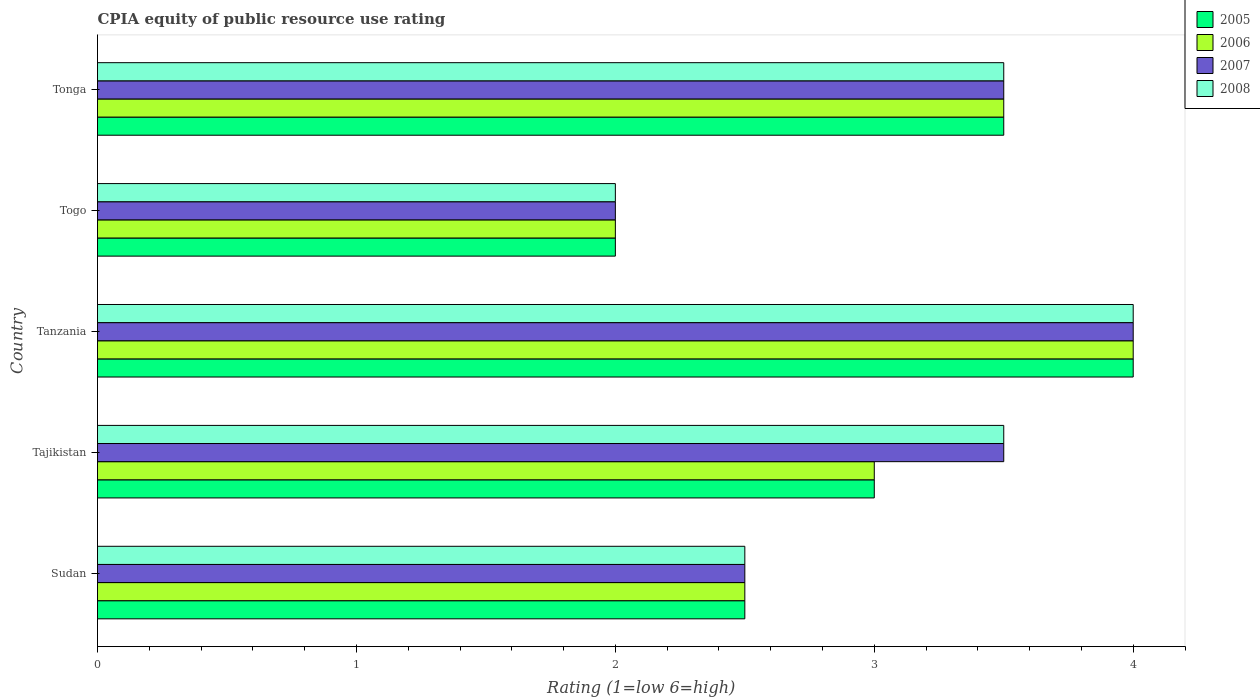How many bars are there on the 2nd tick from the top?
Make the answer very short. 4. What is the label of the 4th group of bars from the top?
Offer a very short reply. Tajikistan. In how many cases, is the number of bars for a given country not equal to the number of legend labels?
Keep it short and to the point. 0. What is the CPIA rating in 2007 in Sudan?
Your answer should be very brief. 2.5. Across all countries, what is the minimum CPIA rating in 2005?
Offer a very short reply. 2. In which country was the CPIA rating in 2008 maximum?
Give a very brief answer. Tanzania. In which country was the CPIA rating in 2005 minimum?
Give a very brief answer. Togo. What is the total CPIA rating in 2007 in the graph?
Keep it short and to the point. 15.5. What is the difference between the CPIA rating in 2005 in Tajikistan and that in Togo?
Provide a short and direct response. 1. What is the difference between the CPIA rating in 2005 in Sudan and the CPIA rating in 2008 in Togo?
Provide a short and direct response. 0.5. What is the average CPIA rating in 2006 per country?
Your answer should be very brief. 3. What is the difference between the CPIA rating in 2006 and CPIA rating in 2007 in Togo?
Your answer should be very brief. 0. What is the ratio of the CPIA rating in 2007 in Togo to that in Tonga?
Give a very brief answer. 0.57. Is the CPIA rating in 2006 in Sudan less than that in Tajikistan?
Provide a short and direct response. Yes. What is the difference between the highest and the second highest CPIA rating in 2007?
Make the answer very short. 0.5. In how many countries, is the CPIA rating in 2007 greater than the average CPIA rating in 2007 taken over all countries?
Your answer should be compact. 3. Is the sum of the CPIA rating in 2007 in Sudan and Togo greater than the maximum CPIA rating in 2006 across all countries?
Your answer should be very brief. Yes. Is it the case that in every country, the sum of the CPIA rating in 2005 and CPIA rating in 2007 is greater than the sum of CPIA rating in 2006 and CPIA rating in 2008?
Give a very brief answer. No. What does the 3rd bar from the top in Togo represents?
Provide a succinct answer. 2006. What does the 2nd bar from the bottom in Tajikistan represents?
Make the answer very short. 2006. How many bars are there?
Give a very brief answer. 20. What is the difference between two consecutive major ticks on the X-axis?
Give a very brief answer. 1. Are the values on the major ticks of X-axis written in scientific E-notation?
Your answer should be compact. No. Does the graph contain grids?
Provide a short and direct response. No. Where does the legend appear in the graph?
Ensure brevity in your answer.  Top right. How many legend labels are there?
Provide a short and direct response. 4. What is the title of the graph?
Offer a very short reply. CPIA equity of public resource use rating. What is the label or title of the Y-axis?
Give a very brief answer. Country. What is the Rating (1=low 6=high) in 2008 in Sudan?
Give a very brief answer. 2.5. What is the Rating (1=low 6=high) in 2007 in Tajikistan?
Provide a succinct answer. 3.5. What is the Rating (1=low 6=high) of 2008 in Tajikistan?
Your answer should be very brief. 3.5. What is the Rating (1=low 6=high) of 2007 in Tanzania?
Offer a very short reply. 4. What is the Rating (1=low 6=high) in 2006 in Togo?
Provide a succinct answer. 2. What is the Rating (1=low 6=high) of 2007 in Togo?
Provide a succinct answer. 2. Across all countries, what is the maximum Rating (1=low 6=high) of 2005?
Offer a terse response. 4. What is the total Rating (1=low 6=high) of 2005 in the graph?
Ensure brevity in your answer.  15. What is the total Rating (1=low 6=high) of 2006 in the graph?
Make the answer very short. 15. What is the total Rating (1=low 6=high) in 2007 in the graph?
Make the answer very short. 15.5. What is the difference between the Rating (1=low 6=high) in 2005 in Sudan and that in Tajikistan?
Ensure brevity in your answer.  -0.5. What is the difference between the Rating (1=low 6=high) of 2006 in Sudan and that in Tajikistan?
Provide a succinct answer. -0.5. What is the difference between the Rating (1=low 6=high) of 2007 in Sudan and that in Tajikistan?
Ensure brevity in your answer.  -1. What is the difference between the Rating (1=low 6=high) of 2007 in Sudan and that in Tanzania?
Your answer should be very brief. -1.5. What is the difference between the Rating (1=low 6=high) in 2008 in Sudan and that in Tanzania?
Provide a succinct answer. -1.5. What is the difference between the Rating (1=low 6=high) of 2006 in Sudan and that in Tonga?
Your answer should be very brief. -1. What is the difference between the Rating (1=low 6=high) in 2007 in Sudan and that in Tonga?
Keep it short and to the point. -1. What is the difference between the Rating (1=low 6=high) in 2007 in Tajikistan and that in Tanzania?
Your answer should be compact. -0.5. What is the difference between the Rating (1=low 6=high) of 2008 in Tajikistan and that in Tanzania?
Your answer should be compact. -0.5. What is the difference between the Rating (1=low 6=high) of 2005 in Tajikistan and that in Togo?
Make the answer very short. 1. What is the difference between the Rating (1=low 6=high) of 2006 in Tajikistan and that in Togo?
Offer a very short reply. 1. What is the difference between the Rating (1=low 6=high) in 2007 in Tajikistan and that in Togo?
Offer a very short reply. 1.5. What is the difference between the Rating (1=low 6=high) in 2006 in Tanzania and that in Tonga?
Make the answer very short. 0.5. What is the difference between the Rating (1=low 6=high) of 2005 in Togo and that in Tonga?
Offer a terse response. -1.5. What is the difference between the Rating (1=low 6=high) in 2008 in Togo and that in Tonga?
Give a very brief answer. -1.5. What is the difference between the Rating (1=low 6=high) in 2005 in Sudan and the Rating (1=low 6=high) in 2006 in Tajikistan?
Your answer should be compact. -0.5. What is the difference between the Rating (1=low 6=high) of 2005 in Sudan and the Rating (1=low 6=high) of 2008 in Tajikistan?
Make the answer very short. -1. What is the difference between the Rating (1=low 6=high) of 2006 in Sudan and the Rating (1=low 6=high) of 2007 in Tajikistan?
Ensure brevity in your answer.  -1. What is the difference between the Rating (1=low 6=high) of 2007 in Sudan and the Rating (1=low 6=high) of 2008 in Tajikistan?
Make the answer very short. -1. What is the difference between the Rating (1=low 6=high) in 2005 in Sudan and the Rating (1=low 6=high) in 2007 in Tanzania?
Ensure brevity in your answer.  -1.5. What is the difference between the Rating (1=low 6=high) in 2006 in Sudan and the Rating (1=low 6=high) in 2007 in Tanzania?
Your answer should be compact. -1.5. What is the difference between the Rating (1=low 6=high) of 2006 in Sudan and the Rating (1=low 6=high) of 2008 in Tanzania?
Give a very brief answer. -1.5. What is the difference between the Rating (1=low 6=high) in 2005 in Sudan and the Rating (1=low 6=high) in 2007 in Togo?
Offer a terse response. 0.5. What is the difference between the Rating (1=low 6=high) in 2006 in Sudan and the Rating (1=low 6=high) in 2007 in Togo?
Give a very brief answer. 0.5. What is the difference between the Rating (1=low 6=high) of 2006 in Sudan and the Rating (1=low 6=high) of 2008 in Togo?
Your response must be concise. 0.5. What is the difference between the Rating (1=low 6=high) of 2005 in Sudan and the Rating (1=low 6=high) of 2006 in Tonga?
Your answer should be compact. -1. What is the difference between the Rating (1=low 6=high) in 2005 in Sudan and the Rating (1=low 6=high) in 2007 in Tonga?
Your answer should be compact. -1. What is the difference between the Rating (1=low 6=high) of 2007 in Sudan and the Rating (1=low 6=high) of 2008 in Tonga?
Your response must be concise. -1. What is the difference between the Rating (1=low 6=high) of 2005 in Tajikistan and the Rating (1=low 6=high) of 2007 in Tanzania?
Your answer should be very brief. -1. What is the difference between the Rating (1=low 6=high) in 2005 in Tajikistan and the Rating (1=low 6=high) in 2008 in Tanzania?
Provide a succinct answer. -1. What is the difference between the Rating (1=low 6=high) in 2006 in Tajikistan and the Rating (1=low 6=high) in 2007 in Tanzania?
Your answer should be very brief. -1. What is the difference between the Rating (1=low 6=high) in 2007 in Tajikistan and the Rating (1=low 6=high) in 2008 in Tanzania?
Give a very brief answer. -0.5. What is the difference between the Rating (1=low 6=high) of 2005 in Tajikistan and the Rating (1=low 6=high) of 2006 in Togo?
Offer a terse response. 1. What is the difference between the Rating (1=low 6=high) of 2005 in Tajikistan and the Rating (1=low 6=high) of 2007 in Togo?
Your answer should be very brief. 1. What is the difference between the Rating (1=low 6=high) of 2005 in Tajikistan and the Rating (1=low 6=high) of 2008 in Togo?
Offer a terse response. 1. What is the difference between the Rating (1=low 6=high) of 2006 in Tajikistan and the Rating (1=low 6=high) of 2008 in Togo?
Make the answer very short. 1. What is the difference between the Rating (1=low 6=high) in 2007 in Tajikistan and the Rating (1=low 6=high) in 2008 in Togo?
Offer a very short reply. 1.5. What is the difference between the Rating (1=low 6=high) in 2005 in Tajikistan and the Rating (1=low 6=high) in 2007 in Tonga?
Provide a short and direct response. -0.5. What is the difference between the Rating (1=low 6=high) in 2006 in Tajikistan and the Rating (1=low 6=high) in 2008 in Tonga?
Your answer should be compact. -0.5. What is the difference between the Rating (1=low 6=high) of 2007 in Tajikistan and the Rating (1=low 6=high) of 2008 in Tonga?
Offer a terse response. 0. What is the difference between the Rating (1=low 6=high) of 2005 in Tanzania and the Rating (1=low 6=high) of 2006 in Togo?
Keep it short and to the point. 2. What is the difference between the Rating (1=low 6=high) of 2005 in Tanzania and the Rating (1=low 6=high) of 2008 in Togo?
Provide a short and direct response. 2. What is the difference between the Rating (1=low 6=high) in 2006 in Tanzania and the Rating (1=low 6=high) in 2007 in Togo?
Offer a terse response. 2. What is the difference between the Rating (1=low 6=high) of 2006 in Tanzania and the Rating (1=low 6=high) of 2008 in Togo?
Offer a very short reply. 2. What is the difference between the Rating (1=low 6=high) of 2005 in Tanzania and the Rating (1=low 6=high) of 2006 in Tonga?
Offer a terse response. 0.5. What is the difference between the Rating (1=low 6=high) in 2005 in Tanzania and the Rating (1=low 6=high) in 2008 in Tonga?
Provide a short and direct response. 0.5. What is the difference between the Rating (1=low 6=high) of 2006 in Tanzania and the Rating (1=low 6=high) of 2007 in Tonga?
Offer a very short reply. 0.5. What is the difference between the Rating (1=low 6=high) in 2007 in Tanzania and the Rating (1=low 6=high) in 2008 in Tonga?
Your answer should be very brief. 0.5. What is the difference between the Rating (1=low 6=high) in 2005 in Togo and the Rating (1=low 6=high) in 2007 in Tonga?
Your answer should be very brief. -1.5. What is the difference between the Rating (1=low 6=high) of 2005 in Togo and the Rating (1=low 6=high) of 2008 in Tonga?
Give a very brief answer. -1.5. What is the difference between the Rating (1=low 6=high) of 2006 in Togo and the Rating (1=low 6=high) of 2007 in Tonga?
Provide a short and direct response. -1.5. What is the average Rating (1=low 6=high) in 2005 per country?
Your response must be concise. 3. What is the average Rating (1=low 6=high) in 2007 per country?
Give a very brief answer. 3.1. What is the difference between the Rating (1=low 6=high) of 2005 and Rating (1=low 6=high) of 2007 in Sudan?
Your response must be concise. 0. What is the difference between the Rating (1=low 6=high) in 2005 and Rating (1=low 6=high) in 2008 in Tajikistan?
Give a very brief answer. -0.5. What is the difference between the Rating (1=low 6=high) in 2005 and Rating (1=low 6=high) in 2008 in Tanzania?
Offer a very short reply. 0. What is the difference between the Rating (1=low 6=high) of 2006 and Rating (1=low 6=high) of 2008 in Tanzania?
Offer a very short reply. 0. What is the difference between the Rating (1=low 6=high) of 2007 and Rating (1=low 6=high) of 2008 in Tanzania?
Your response must be concise. 0. What is the difference between the Rating (1=low 6=high) in 2005 and Rating (1=low 6=high) in 2007 in Togo?
Offer a terse response. 0. What is the difference between the Rating (1=low 6=high) in 2006 and Rating (1=low 6=high) in 2007 in Togo?
Give a very brief answer. 0. What is the difference between the Rating (1=low 6=high) of 2006 and Rating (1=low 6=high) of 2008 in Togo?
Your answer should be compact. 0. What is the difference between the Rating (1=low 6=high) in 2007 and Rating (1=low 6=high) in 2008 in Togo?
Make the answer very short. 0. What is the difference between the Rating (1=low 6=high) of 2005 and Rating (1=low 6=high) of 2006 in Tonga?
Offer a terse response. 0. What is the difference between the Rating (1=low 6=high) of 2005 and Rating (1=low 6=high) of 2007 in Tonga?
Provide a succinct answer. 0. What is the difference between the Rating (1=low 6=high) of 2005 and Rating (1=low 6=high) of 2008 in Tonga?
Your answer should be compact. 0. What is the difference between the Rating (1=low 6=high) in 2006 and Rating (1=low 6=high) in 2007 in Tonga?
Provide a succinct answer. 0. What is the ratio of the Rating (1=low 6=high) of 2007 in Sudan to that in Tajikistan?
Make the answer very short. 0.71. What is the ratio of the Rating (1=low 6=high) in 2008 in Sudan to that in Tajikistan?
Offer a terse response. 0.71. What is the ratio of the Rating (1=low 6=high) of 2005 in Sudan to that in Tanzania?
Give a very brief answer. 0.62. What is the ratio of the Rating (1=low 6=high) of 2005 in Sudan to that in Togo?
Give a very brief answer. 1.25. What is the ratio of the Rating (1=low 6=high) in 2006 in Sudan to that in Togo?
Offer a very short reply. 1.25. What is the ratio of the Rating (1=low 6=high) of 2007 in Sudan to that in Togo?
Provide a short and direct response. 1.25. What is the ratio of the Rating (1=low 6=high) in 2005 in Sudan to that in Tonga?
Your answer should be very brief. 0.71. What is the ratio of the Rating (1=low 6=high) of 2006 in Sudan to that in Tonga?
Offer a terse response. 0.71. What is the ratio of the Rating (1=low 6=high) in 2007 in Sudan to that in Tonga?
Make the answer very short. 0.71. What is the ratio of the Rating (1=low 6=high) in 2008 in Sudan to that in Tonga?
Provide a short and direct response. 0.71. What is the ratio of the Rating (1=low 6=high) of 2006 in Tajikistan to that in Tanzania?
Provide a succinct answer. 0.75. What is the ratio of the Rating (1=low 6=high) in 2007 in Tajikistan to that in Tanzania?
Offer a very short reply. 0.88. What is the ratio of the Rating (1=low 6=high) in 2008 in Tajikistan to that in Tanzania?
Provide a succinct answer. 0.88. What is the ratio of the Rating (1=low 6=high) in 2006 in Tajikistan to that in Togo?
Keep it short and to the point. 1.5. What is the ratio of the Rating (1=low 6=high) of 2007 in Tajikistan to that in Togo?
Make the answer very short. 1.75. What is the ratio of the Rating (1=low 6=high) of 2005 in Tanzania to that in Tonga?
Provide a short and direct response. 1.14. What is the ratio of the Rating (1=low 6=high) of 2007 in Tanzania to that in Tonga?
Keep it short and to the point. 1.14. What is the ratio of the Rating (1=low 6=high) in 2008 in Tanzania to that in Tonga?
Your answer should be very brief. 1.14. What is the ratio of the Rating (1=low 6=high) in 2006 in Togo to that in Tonga?
Offer a very short reply. 0.57. What is the difference between the highest and the second highest Rating (1=low 6=high) in 2005?
Give a very brief answer. 0.5. What is the difference between the highest and the second highest Rating (1=low 6=high) in 2007?
Provide a succinct answer. 0.5. What is the difference between the highest and the second highest Rating (1=low 6=high) of 2008?
Offer a very short reply. 0.5. What is the difference between the highest and the lowest Rating (1=low 6=high) of 2005?
Offer a terse response. 2. What is the difference between the highest and the lowest Rating (1=low 6=high) of 2006?
Your response must be concise. 2. What is the difference between the highest and the lowest Rating (1=low 6=high) in 2007?
Offer a terse response. 2. 